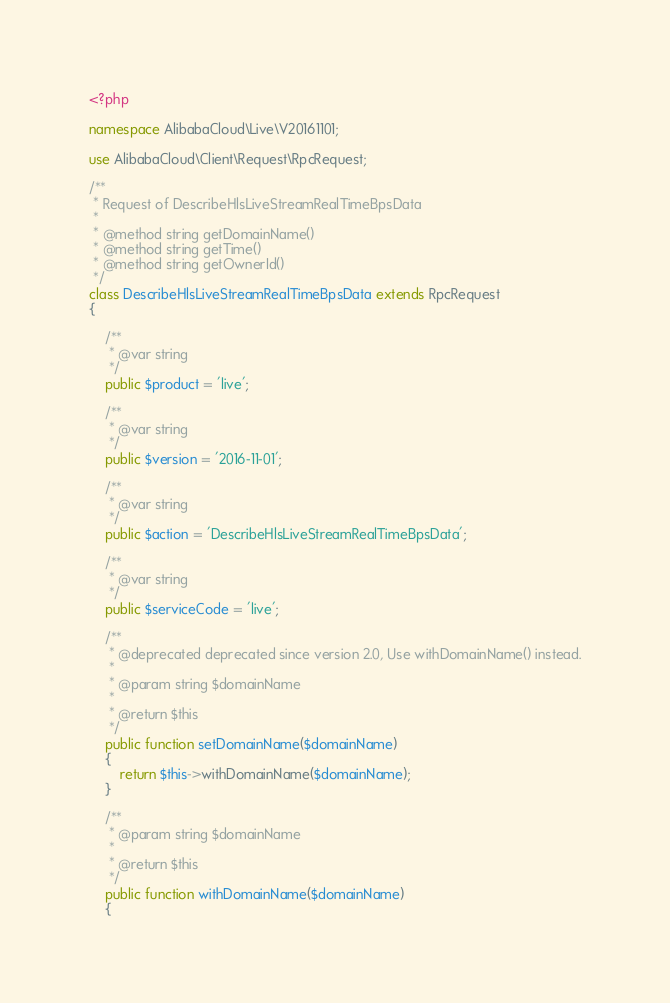<code> <loc_0><loc_0><loc_500><loc_500><_PHP_><?php

namespace AlibabaCloud\Live\V20161101;

use AlibabaCloud\Client\Request\RpcRequest;

/**
 * Request of DescribeHlsLiveStreamRealTimeBpsData
 *
 * @method string getDomainName()
 * @method string getTime()
 * @method string getOwnerId()
 */
class DescribeHlsLiveStreamRealTimeBpsData extends RpcRequest
{

    /**
     * @var string
     */
    public $product = 'live';

    /**
     * @var string
     */
    public $version = '2016-11-01';

    /**
     * @var string
     */
    public $action = 'DescribeHlsLiveStreamRealTimeBpsData';

    /**
     * @var string
     */
    public $serviceCode = 'live';

    /**
     * @deprecated deprecated since version 2.0, Use withDomainName() instead.
     *
     * @param string $domainName
     *
     * @return $this
     */
    public function setDomainName($domainName)
    {
        return $this->withDomainName($domainName);
    }

    /**
     * @param string $domainName
     *
     * @return $this
     */
    public function withDomainName($domainName)
    {</code> 